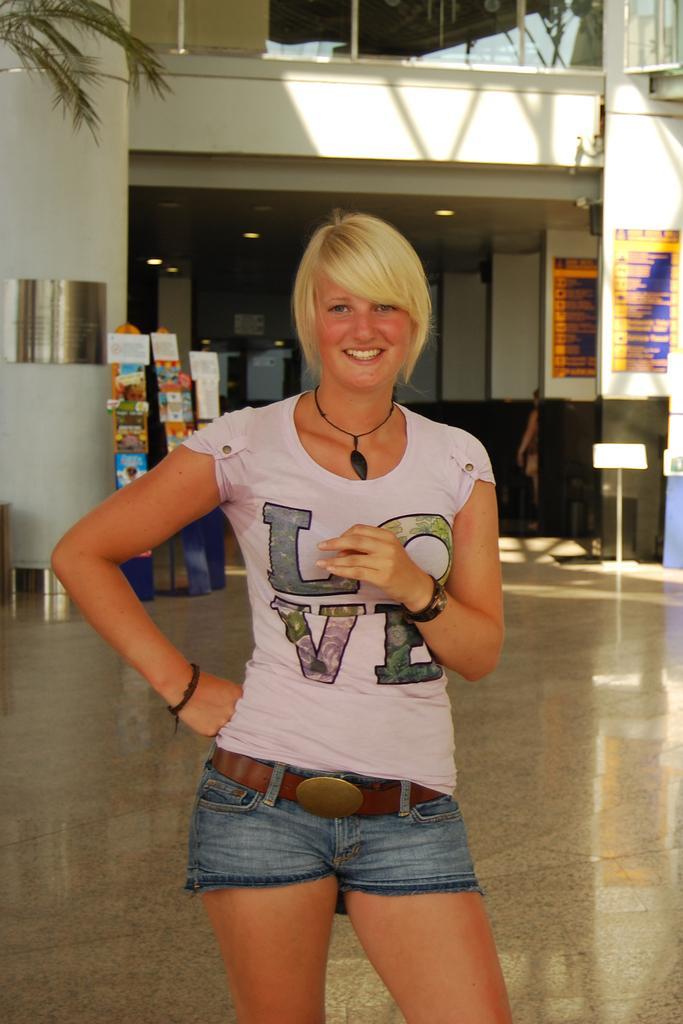Describe this image in one or two sentences. In this image in front there is a person wearing a smile on her smile. At the bottom of the image there is a floor. In the background of the image there is a tree and a building. In front of the building there are boards. 